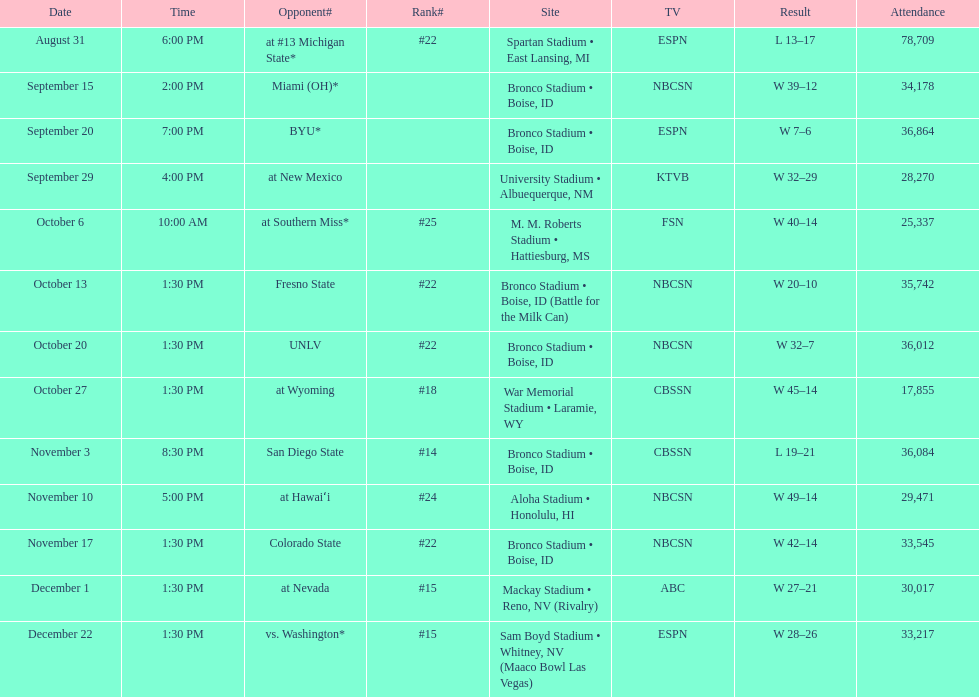What was there top ranked position of the season? #14. 